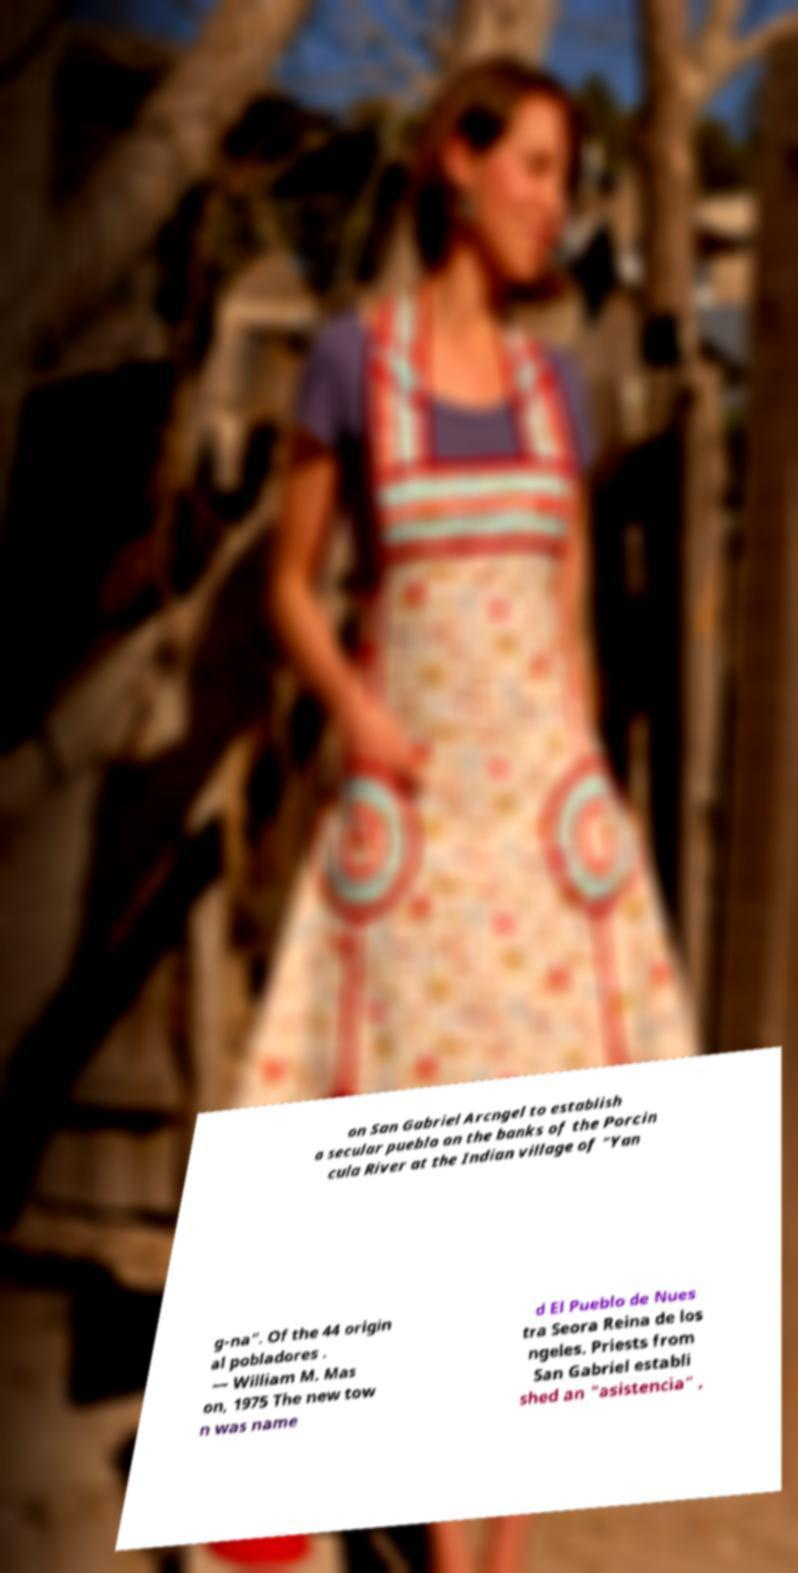Can you accurately transcribe the text from the provided image for me? on San Gabriel Arcngel to establish a secular pueblo on the banks of the Porcin cula River at the Indian village of "Yan g-na". Of the 44 origin al pobladores . — William M. Mas on, 1975 The new tow n was name d El Pueblo de Nues tra Seora Reina de los ngeles. Priests from San Gabriel establi shed an "asistencia" , 